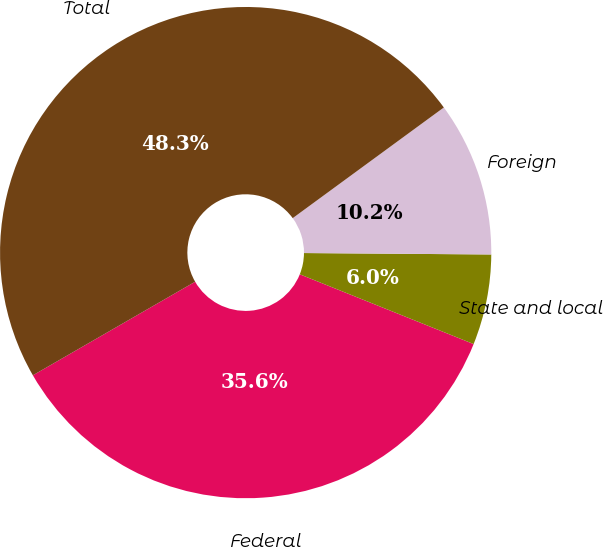Convert chart to OTSL. <chart><loc_0><loc_0><loc_500><loc_500><pie_chart><fcel>Federal<fcel>State and local<fcel>Foreign<fcel>Total<nl><fcel>35.6%<fcel>5.95%<fcel>10.18%<fcel>48.26%<nl></chart> 